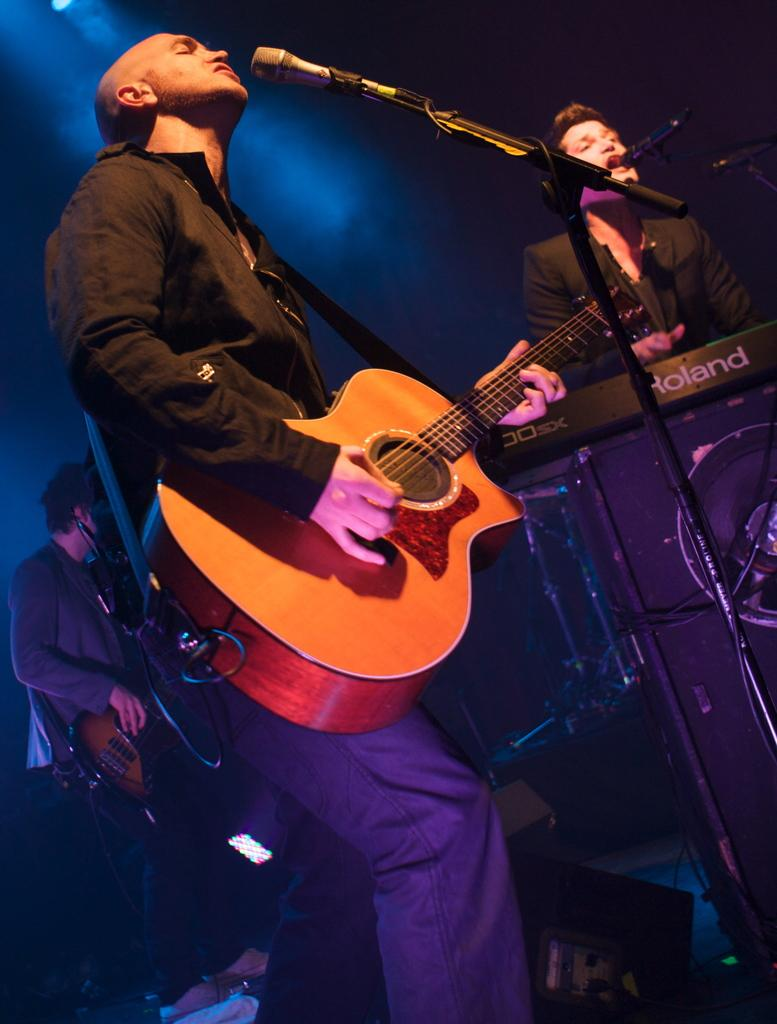What is the man in the image holding? The man is holding a guitar in the image. What is the man doing with the guitar? The man is playing the guitar. Are there any other musicians in the image? Yes, there is a man playing the piano in the image. What is the man playing the piano doing besides playing the piano? The man playing the piano is also singing through a microphone. What type of wax is being used to create the sound from the guitar in the image? There is no wax present in the image, and the guitar's sound is not created using wax. 